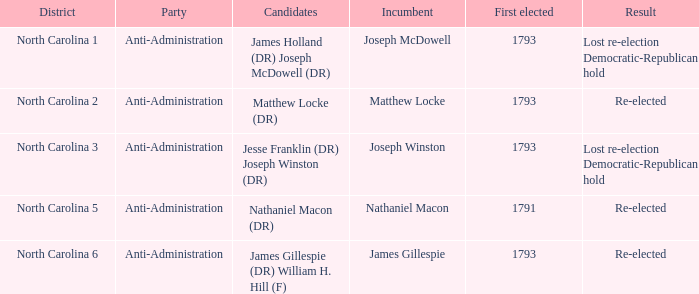Who was the candidate in 1791? Nathaniel Macon (DR). 